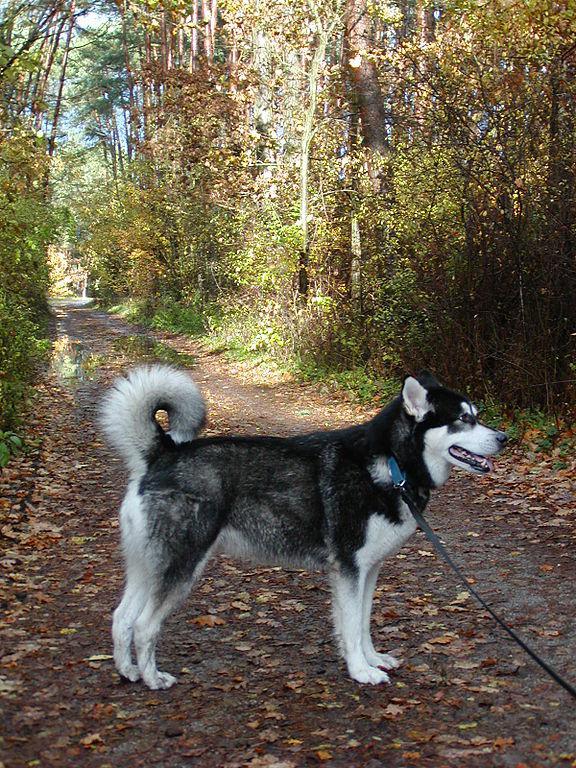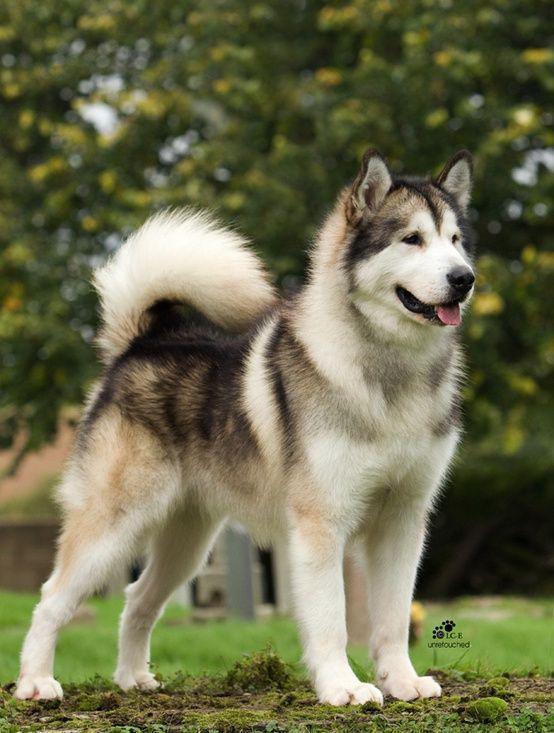The first image is the image on the left, the second image is the image on the right. For the images displayed, is the sentence "Each image contains one dog, and one of the dogs depicted is a husky standing in profile on grass, with white around its eyes and its tail curled inward." factually correct? Answer yes or no. Yes. 